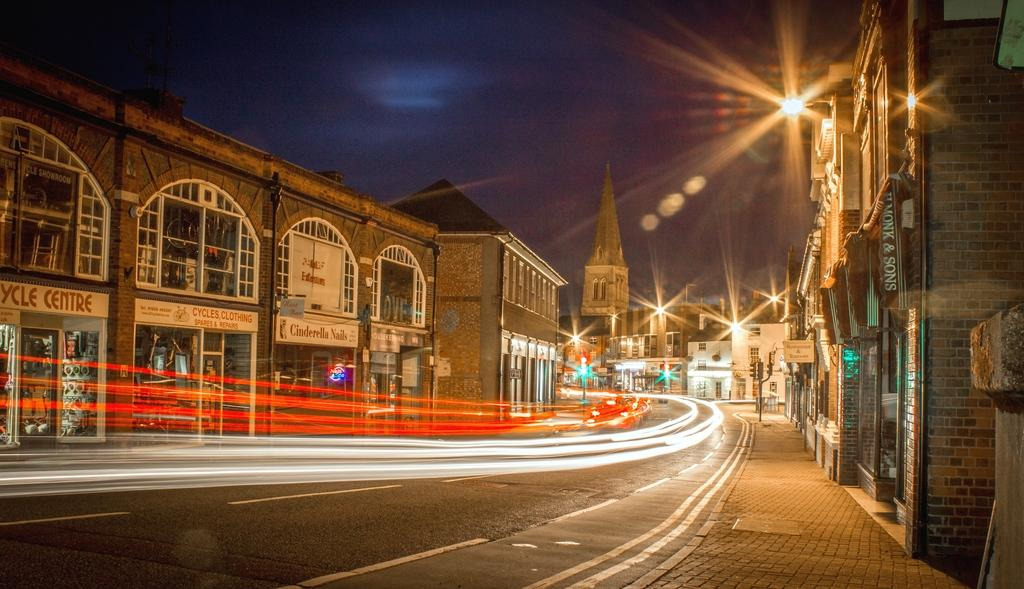What is the main feature of the image? There is a road in the image. What else can be seen along the road? There are lights, buildings, light poles, and traffic signal poles in the image. What is the condition of the sky in the background? The sky in the background is dark. What type of education can be seen taking place in the image? There is no indication of any educational activity in the image. Can you tell me how many worms are crawling on the road in the image? There are no worms present in the image. 